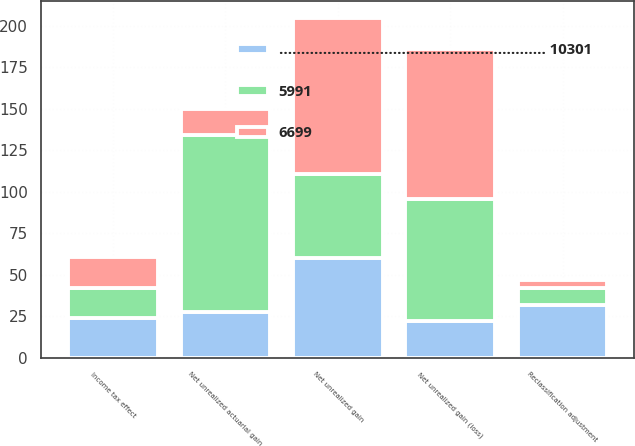<chart> <loc_0><loc_0><loc_500><loc_500><stacked_bar_chart><ecel><fcel>Net unrealized gain<fcel>Income tax effect<fcel>Net unrealized actuarial gain<fcel>Reclassification adjustment<fcel>Net unrealized gain (loss)<nl><fcel>6699<fcel>94<fcel>19<fcel>16<fcel>5<fcel>90<nl><fcel>............................................................. 10301<fcel>60<fcel>24<fcel>28<fcel>32<fcel>22<nl><fcel>5991<fcel>51<fcel>18<fcel>106<fcel>10<fcel>74<nl></chart> 